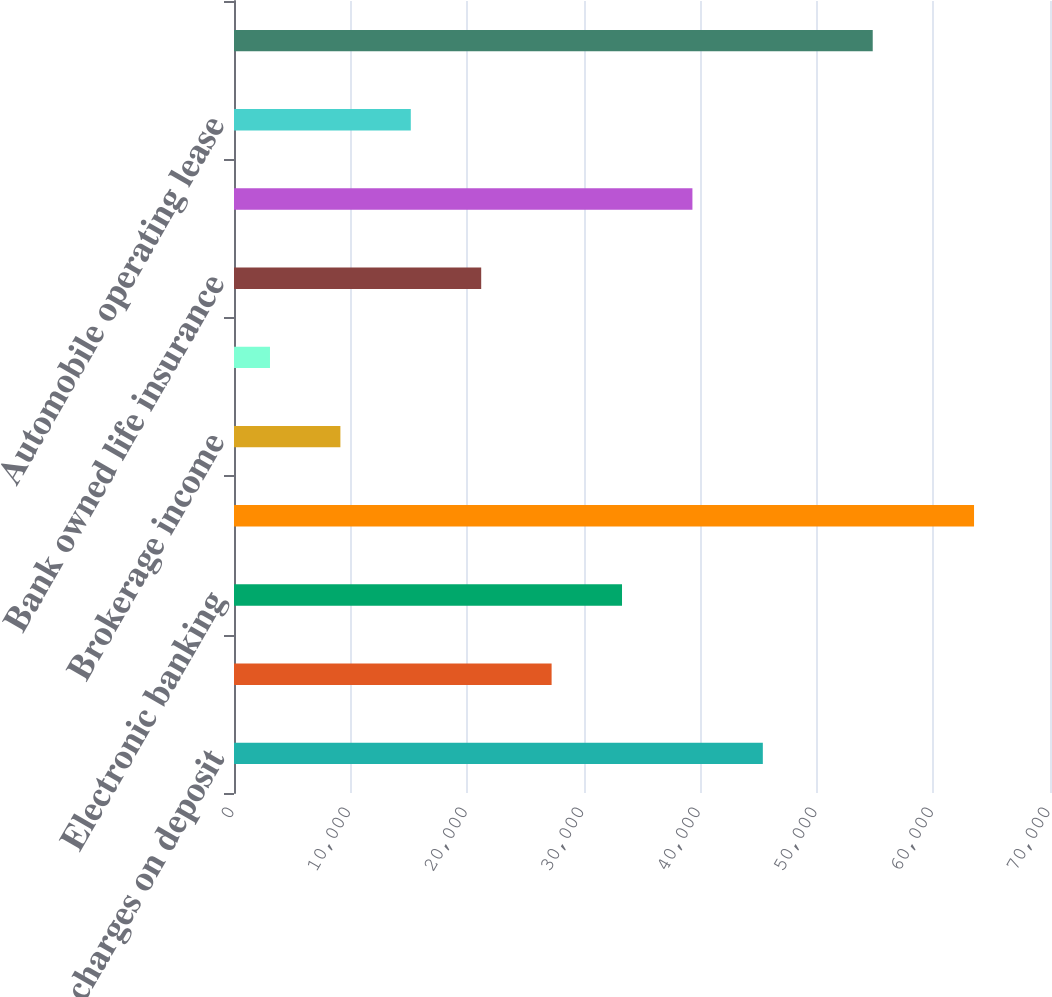Convert chart to OTSL. <chart><loc_0><loc_0><loc_500><loc_500><bar_chart><fcel>Service charges on deposit<fcel>Trust services<fcel>Electronic banking<fcel>Mortgage banking income<fcel>Brokerage income<fcel>Insurance income<fcel>Bank owned life insurance<fcel>Capital markets fees<fcel>Automobile operating lease<fcel>Other income<nl><fcel>45364.9<fcel>27245.8<fcel>33285.5<fcel>63484<fcel>9126.7<fcel>3087<fcel>21206.1<fcel>39325.2<fcel>15166.4<fcel>54793<nl></chart> 